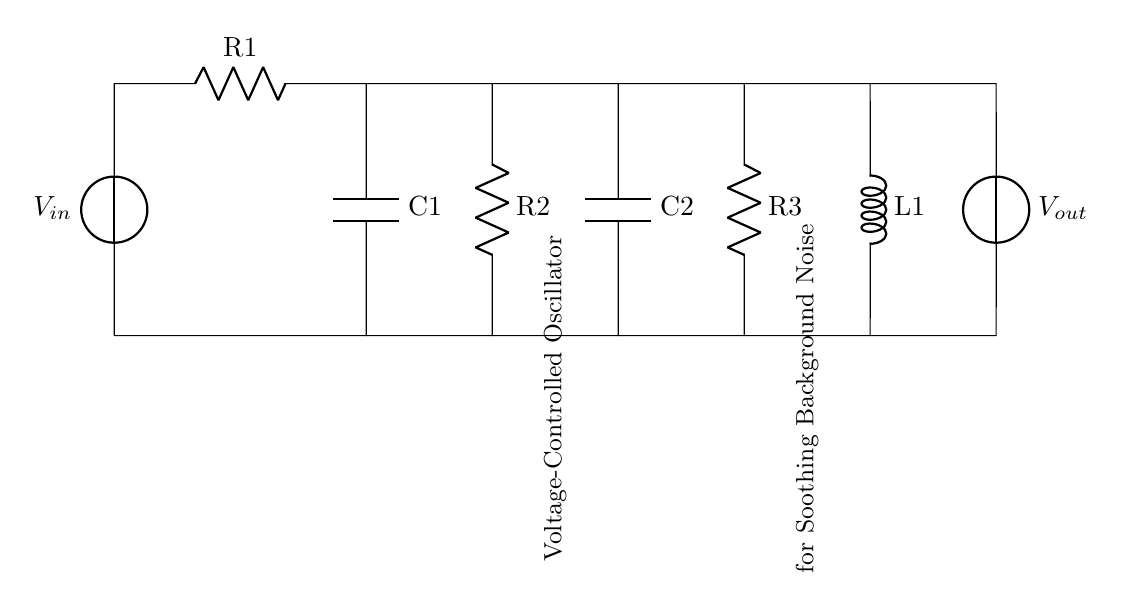What is the function of the two capacitors in this circuit? The capacitors store and release electrical energy, which helps in creating oscillations in the circuit, making them essential for the voltage-controlled oscillator's function.
Answer: Store and release energy What component controls the oscillation frequency? The values of the resistors and capacitors determine the time constants, which in turn control the frequency of oscillation in this voltage-controlled oscillator circuit.
Answer: Resistors and capacitors What is the total number of resistors in the circuit? By counting the diagram, we see there are three resistors labeled R1, R2, and R3, making the total count three.
Answer: Three What is the purpose of the inductor in the circuit? The inductor helps to influence the frequency response along with the resistors and capacitors, aiding in achieving smooth oscillations necessary for soothing background noise.
Answer: Influence frequency response How do the resistors affect the charging time of the capacitors? The resistors increase the resistance in the charging path, which affects how quickly the capacitors charge and discharge, ultimately impacting the oscillation frequency and smoothness of the output signal.
Answer: Increase charging time Which component generates the output voltage? The output voltage is generated by the voltage source, labeled as V_out in the circuit, as it provides the necessary potential for the oscillator to function correctly.
Answer: Voltage source 